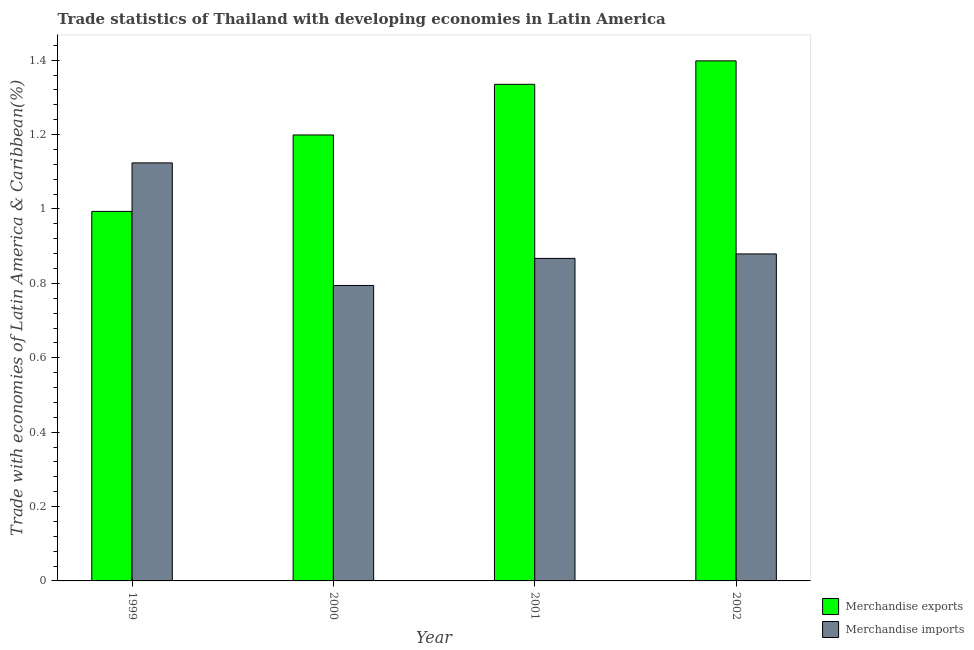How many different coloured bars are there?
Your answer should be very brief. 2. How many groups of bars are there?
Keep it short and to the point. 4. How many bars are there on the 1st tick from the right?
Offer a terse response. 2. In how many cases, is the number of bars for a given year not equal to the number of legend labels?
Make the answer very short. 0. What is the merchandise exports in 2000?
Offer a terse response. 1.2. Across all years, what is the maximum merchandise imports?
Offer a terse response. 1.12. Across all years, what is the minimum merchandise exports?
Offer a very short reply. 0.99. In which year was the merchandise imports maximum?
Offer a very short reply. 1999. In which year was the merchandise imports minimum?
Your response must be concise. 2000. What is the total merchandise imports in the graph?
Make the answer very short. 3.66. What is the difference between the merchandise imports in 1999 and that in 2000?
Your answer should be compact. 0.33. What is the difference between the merchandise exports in 2000 and the merchandise imports in 1999?
Provide a short and direct response. 0.21. What is the average merchandise exports per year?
Your answer should be compact. 1.23. In the year 1999, what is the difference between the merchandise exports and merchandise imports?
Your answer should be compact. 0. What is the ratio of the merchandise imports in 1999 to that in 2000?
Provide a succinct answer. 1.41. Is the merchandise exports in 1999 less than that in 2002?
Offer a very short reply. Yes. Is the difference between the merchandise imports in 1999 and 2001 greater than the difference between the merchandise exports in 1999 and 2001?
Offer a very short reply. No. What is the difference between the highest and the second highest merchandise exports?
Provide a succinct answer. 0.06. What is the difference between the highest and the lowest merchandise exports?
Provide a short and direct response. 0.4. What does the 2nd bar from the right in 2002 represents?
Offer a very short reply. Merchandise exports. How many years are there in the graph?
Make the answer very short. 4. What is the difference between two consecutive major ticks on the Y-axis?
Offer a terse response. 0.2. Are the values on the major ticks of Y-axis written in scientific E-notation?
Keep it short and to the point. No. Does the graph contain any zero values?
Your answer should be very brief. No. What is the title of the graph?
Your response must be concise. Trade statistics of Thailand with developing economies in Latin America. Does "Arms exports" appear as one of the legend labels in the graph?
Keep it short and to the point. No. What is the label or title of the X-axis?
Your response must be concise. Year. What is the label or title of the Y-axis?
Offer a terse response. Trade with economies of Latin America & Caribbean(%). What is the Trade with economies of Latin America & Caribbean(%) of Merchandise exports in 1999?
Provide a succinct answer. 0.99. What is the Trade with economies of Latin America & Caribbean(%) of Merchandise imports in 1999?
Ensure brevity in your answer.  1.12. What is the Trade with economies of Latin America & Caribbean(%) of Merchandise exports in 2000?
Give a very brief answer. 1.2. What is the Trade with economies of Latin America & Caribbean(%) in Merchandise imports in 2000?
Keep it short and to the point. 0.79. What is the Trade with economies of Latin America & Caribbean(%) of Merchandise exports in 2001?
Offer a very short reply. 1.34. What is the Trade with economies of Latin America & Caribbean(%) in Merchandise imports in 2001?
Your response must be concise. 0.87. What is the Trade with economies of Latin America & Caribbean(%) in Merchandise exports in 2002?
Keep it short and to the point. 1.4. What is the Trade with economies of Latin America & Caribbean(%) of Merchandise imports in 2002?
Your answer should be compact. 0.88. Across all years, what is the maximum Trade with economies of Latin America & Caribbean(%) in Merchandise exports?
Give a very brief answer. 1.4. Across all years, what is the maximum Trade with economies of Latin America & Caribbean(%) in Merchandise imports?
Make the answer very short. 1.12. Across all years, what is the minimum Trade with economies of Latin America & Caribbean(%) in Merchandise exports?
Offer a very short reply. 0.99. Across all years, what is the minimum Trade with economies of Latin America & Caribbean(%) in Merchandise imports?
Offer a very short reply. 0.79. What is the total Trade with economies of Latin America & Caribbean(%) in Merchandise exports in the graph?
Your answer should be compact. 4.93. What is the total Trade with economies of Latin America & Caribbean(%) in Merchandise imports in the graph?
Ensure brevity in your answer.  3.66. What is the difference between the Trade with economies of Latin America & Caribbean(%) of Merchandise exports in 1999 and that in 2000?
Make the answer very short. -0.21. What is the difference between the Trade with economies of Latin America & Caribbean(%) of Merchandise imports in 1999 and that in 2000?
Your response must be concise. 0.33. What is the difference between the Trade with economies of Latin America & Caribbean(%) in Merchandise exports in 1999 and that in 2001?
Give a very brief answer. -0.34. What is the difference between the Trade with economies of Latin America & Caribbean(%) in Merchandise imports in 1999 and that in 2001?
Offer a terse response. 0.26. What is the difference between the Trade with economies of Latin America & Caribbean(%) of Merchandise exports in 1999 and that in 2002?
Give a very brief answer. -0.4. What is the difference between the Trade with economies of Latin America & Caribbean(%) in Merchandise imports in 1999 and that in 2002?
Offer a terse response. 0.24. What is the difference between the Trade with economies of Latin America & Caribbean(%) in Merchandise exports in 2000 and that in 2001?
Provide a short and direct response. -0.14. What is the difference between the Trade with economies of Latin America & Caribbean(%) in Merchandise imports in 2000 and that in 2001?
Offer a terse response. -0.07. What is the difference between the Trade with economies of Latin America & Caribbean(%) in Merchandise exports in 2000 and that in 2002?
Your response must be concise. -0.2. What is the difference between the Trade with economies of Latin America & Caribbean(%) in Merchandise imports in 2000 and that in 2002?
Keep it short and to the point. -0.08. What is the difference between the Trade with economies of Latin America & Caribbean(%) in Merchandise exports in 2001 and that in 2002?
Give a very brief answer. -0.06. What is the difference between the Trade with economies of Latin America & Caribbean(%) in Merchandise imports in 2001 and that in 2002?
Make the answer very short. -0.01. What is the difference between the Trade with economies of Latin America & Caribbean(%) in Merchandise exports in 1999 and the Trade with economies of Latin America & Caribbean(%) in Merchandise imports in 2000?
Provide a succinct answer. 0.2. What is the difference between the Trade with economies of Latin America & Caribbean(%) of Merchandise exports in 1999 and the Trade with economies of Latin America & Caribbean(%) of Merchandise imports in 2001?
Your answer should be very brief. 0.13. What is the difference between the Trade with economies of Latin America & Caribbean(%) of Merchandise exports in 1999 and the Trade with economies of Latin America & Caribbean(%) of Merchandise imports in 2002?
Offer a very short reply. 0.11. What is the difference between the Trade with economies of Latin America & Caribbean(%) in Merchandise exports in 2000 and the Trade with economies of Latin America & Caribbean(%) in Merchandise imports in 2001?
Your answer should be compact. 0.33. What is the difference between the Trade with economies of Latin America & Caribbean(%) in Merchandise exports in 2000 and the Trade with economies of Latin America & Caribbean(%) in Merchandise imports in 2002?
Offer a terse response. 0.32. What is the difference between the Trade with economies of Latin America & Caribbean(%) in Merchandise exports in 2001 and the Trade with economies of Latin America & Caribbean(%) in Merchandise imports in 2002?
Your response must be concise. 0.46. What is the average Trade with economies of Latin America & Caribbean(%) in Merchandise exports per year?
Provide a succinct answer. 1.23. What is the average Trade with economies of Latin America & Caribbean(%) of Merchandise imports per year?
Offer a terse response. 0.92. In the year 1999, what is the difference between the Trade with economies of Latin America & Caribbean(%) of Merchandise exports and Trade with economies of Latin America & Caribbean(%) of Merchandise imports?
Make the answer very short. -0.13. In the year 2000, what is the difference between the Trade with economies of Latin America & Caribbean(%) in Merchandise exports and Trade with economies of Latin America & Caribbean(%) in Merchandise imports?
Ensure brevity in your answer.  0.4. In the year 2001, what is the difference between the Trade with economies of Latin America & Caribbean(%) in Merchandise exports and Trade with economies of Latin America & Caribbean(%) in Merchandise imports?
Offer a very short reply. 0.47. In the year 2002, what is the difference between the Trade with economies of Latin America & Caribbean(%) in Merchandise exports and Trade with economies of Latin America & Caribbean(%) in Merchandise imports?
Keep it short and to the point. 0.52. What is the ratio of the Trade with economies of Latin America & Caribbean(%) in Merchandise exports in 1999 to that in 2000?
Provide a succinct answer. 0.83. What is the ratio of the Trade with economies of Latin America & Caribbean(%) in Merchandise imports in 1999 to that in 2000?
Give a very brief answer. 1.41. What is the ratio of the Trade with economies of Latin America & Caribbean(%) of Merchandise exports in 1999 to that in 2001?
Your answer should be compact. 0.74. What is the ratio of the Trade with economies of Latin America & Caribbean(%) in Merchandise imports in 1999 to that in 2001?
Give a very brief answer. 1.3. What is the ratio of the Trade with economies of Latin America & Caribbean(%) of Merchandise exports in 1999 to that in 2002?
Keep it short and to the point. 0.71. What is the ratio of the Trade with economies of Latin America & Caribbean(%) in Merchandise imports in 1999 to that in 2002?
Make the answer very short. 1.28. What is the ratio of the Trade with economies of Latin America & Caribbean(%) in Merchandise exports in 2000 to that in 2001?
Your answer should be compact. 0.9. What is the ratio of the Trade with economies of Latin America & Caribbean(%) in Merchandise imports in 2000 to that in 2001?
Provide a succinct answer. 0.92. What is the ratio of the Trade with economies of Latin America & Caribbean(%) of Merchandise exports in 2000 to that in 2002?
Your answer should be compact. 0.86. What is the ratio of the Trade with economies of Latin America & Caribbean(%) of Merchandise imports in 2000 to that in 2002?
Give a very brief answer. 0.9. What is the ratio of the Trade with economies of Latin America & Caribbean(%) of Merchandise exports in 2001 to that in 2002?
Make the answer very short. 0.95. What is the ratio of the Trade with economies of Latin America & Caribbean(%) in Merchandise imports in 2001 to that in 2002?
Provide a short and direct response. 0.99. What is the difference between the highest and the second highest Trade with economies of Latin America & Caribbean(%) of Merchandise exports?
Offer a very short reply. 0.06. What is the difference between the highest and the second highest Trade with economies of Latin America & Caribbean(%) of Merchandise imports?
Make the answer very short. 0.24. What is the difference between the highest and the lowest Trade with economies of Latin America & Caribbean(%) of Merchandise exports?
Make the answer very short. 0.4. What is the difference between the highest and the lowest Trade with economies of Latin America & Caribbean(%) in Merchandise imports?
Keep it short and to the point. 0.33. 